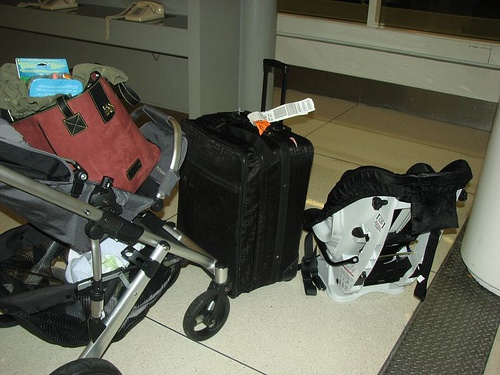Describe the objects in this image and their specific colors. I can see suitcase in black, gray, darkgreen, and darkgray tones, backpack in black, darkgray, and lightgray tones, and handbag in black, brown, and maroon tones in this image. 